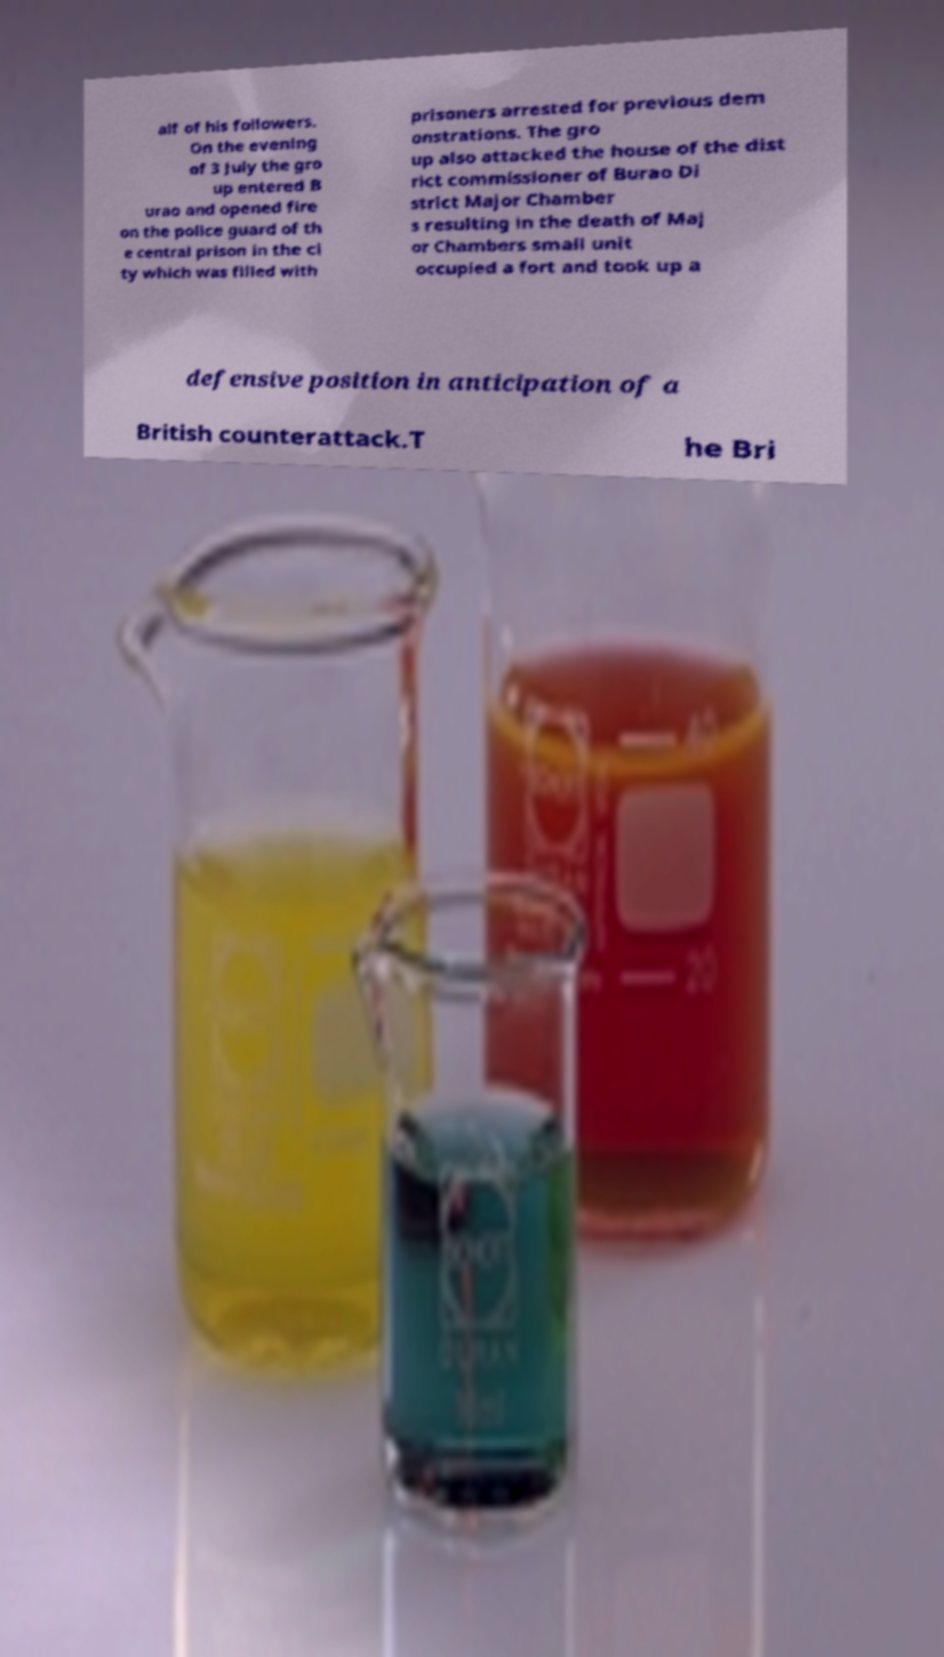Can you read and provide the text displayed in the image?This photo seems to have some interesting text. Can you extract and type it out for me? alf of his followers. On the evening of 3 July the gro up entered B urao and opened fire on the police guard of th e central prison in the ci ty which was filled with prisoners arrested for previous dem onstrations. The gro up also attacked the house of the dist rict commissioner of Burao Di strict Major Chamber s resulting in the death of Maj or Chambers small unit occupied a fort and took up a defensive position in anticipation of a British counterattack.T he Bri 